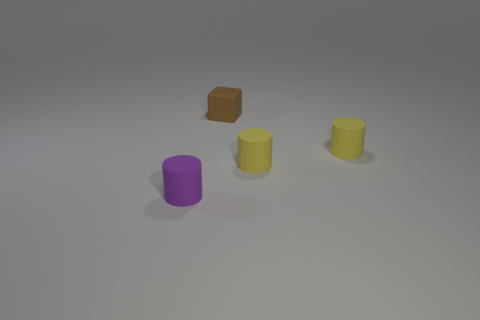Subtract all purple cylinders. How many cylinders are left? 2 Subtract all yellow cylinders. How many cylinders are left? 1 Add 2 rubber cylinders. How many objects exist? 6 Subtract all cylinders. How many objects are left? 1 Add 2 small brown matte cubes. How many small brown matte cubes exist? 3 Subtract 1 brown blocks. How many objects are left? 3 Subtract 2 cylinders. How many cylinders are left? 1 Subtract all red cylinders. Subtract all brown blocks. How many cylinders are left? 3 Subtract all green blocks. How many yellow cylinders are left? 2 Subtract all brown objects. Subtract all tiny blue matte spheres. How many objects are left? 3 